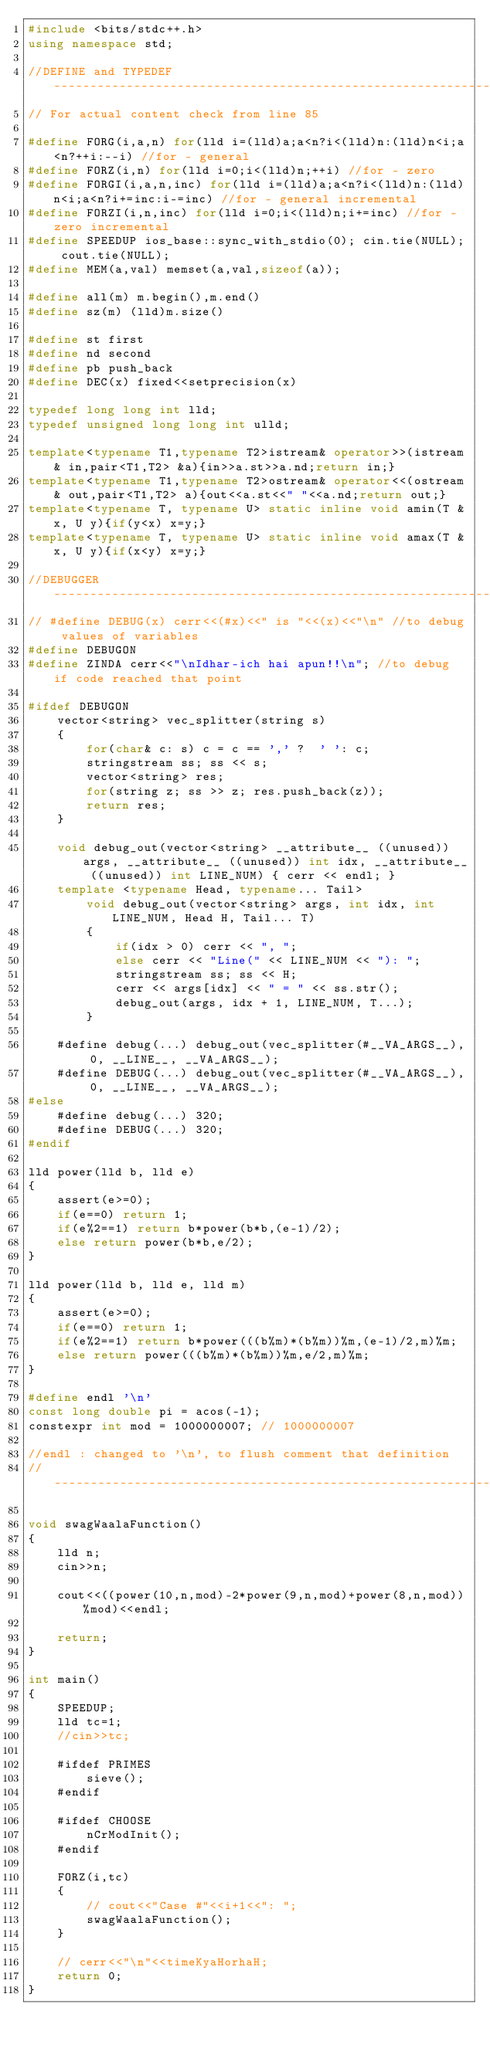Convert code to text. <code><loc_0><loc_0><loc_500><loc_500><_C++_>#include <bits/stdc++.h>
using namespace std;
 
//DEFINE and TYPEDEF--------------------------------------------------------------
// For actual content check from line 85

#define FORG(i,a,n) for(lld i=(lld)a;a<n?i<(lld)n:(lld)n<i;a<n?++i:--i) //for - general
#define FORZ(i,n) for(lld i=0;i<(lld)n;++i) //for - zero
#define FORGI(i,a,n,inc) for(lld i=(lld)a;a<n?i<(lld)n:(lld)n<i;a<n?i+=inc:i-=inc) //for - general incremental
#define FORZI(i,n,inc) for(lld i=0;i<(lld)n;i+=inc) //for - zero incremental
#define SPEEDUP ios_base::sync_with_stdio(0); cin.tie(NULL); cout.tie(NULL);
#define MEM(a,val) memset(a,val,sizeof(a));
 
#define all(m) m.begin(),m.end()
#define sz(m) (lld)m.size()
 
#define st first
#define nd second
#define pb push_back
#define DEC(x) fixed<<setprecision(x)
 
typedef long long int lld;
typedef unsigned long long int ulld;
 
template<typename T1,typename T2>istream& operator>>(istream& in,pair<T1,T2> &a){in>>a.st>>a.nd;return in;}
template<typename T1,typename T2>ostream& operator<<(ostream& out,pair<T1,T2> a){out<<a.st<<" "<<a.nd;return out;}
template<typename T, typename U> static inline void amin(T &x, U y){if(y<x) x=y;}
template<typename T, typename U> static inline void amax(T &x, U y){if(x<y) x=y;}

//DEBUGGER------------------------------------------------------------------------
// #define DEBUG(x) cerr<<(#x)<<" is "<<(x)<<"\n" //to debug values of variables
#define DEBUGON
#define ZINDA cerr<<"\nIdhar-ich hai apun!!\n"; //to debug if code reached that point

#ifdef DEBUGON
	vector<string> vec_splitter(string s) 
	{
		for(char& c: s) c = c == ',' ?  ' ': c;
		stringstream ss; ss << s;
		vector<string> res;
		for(string z; ss >> z; res.push_back(z));
		return res;
	}

	void debug_out(vector<string> __attribute__ ((unused)) args, __attribute__ ((unused)) int idx, __attribute__ ((unused)) int LINE_NUM) { cerr << endl; } 
	template <typename Head, typename... Tail>
		void debug_out(vector<string> args, int idx, int LINE_NUM, Head H, Tail... T) 
		{
			if(idx > 0) cerr << ", "; 
			else cerr << "Line(" << LINE_NUM << "): ";
			stringstream ss; ss << H;
			cerr << args[idx] << " = " << ss.str();
			debug_out(args, idx + 1, LINE_NUM, T...);
		}

	#define debug(...) debug_out(vec_splitter(#__VA_ARGS__), 0, __LINE__, __VA_ARGS__);
	#define DEBUG(...) debug_out(vec_splitter(#__VA_ARGS__), 0, __LINE__, __VA_ARGS__);
#else
	#define debug(...) 320;
	#define DEBUG(...) 320;
#endif

lld power(lld b, lld e)
{
	assert(e>=0);
    if(e==0) return 1;
    if(e%2==1) return b*power(b*b,(e-1)/2);
    else return power(b*b,e/2);
}
 
lld power(lld b, lld e, lld m)
{
	assert(e>=0);
	if(e==0) return 1;
	if(e%2==1) return b*power(((b%m)*(b%m))%m,(e-1)/2,m)%m;
	else return power(((b%m)*(b%m))%m,e/2,m)%m;
}

#define endl '\n'
const long double pi = acos(-1);
constexpr int mod = 1000000007; // 1000000007

//endl : changed to '\n', to flush comment that definition
//--------------------------------------------------------------------------------

void swagWaalaFunction()
{
	lld n;
	cin>>n;

	cout<<((power(10,n,mod)-2*power(9,n,mod)+power(8,n,mod))%mod)<<endl;

	return;
}

int main()
{
    SPEEDUP;
 	lld tc=1;
 	//cin>>tc;

 	#ifdef PRIMES
 		sieve();
 	#endif

 	#ifdef CHOOSE
 		nCrModInit();
 	#endif

	FORZ(i,tc)
 	{
 		// cout<<"Case #"<<i+1<<": ";
 		swagWaalaFunction();
	}
	
	// cerr<<"\n"<<timeKyaHorhaH; 	
 	return 0;
}
</code> 